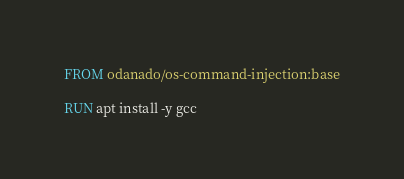Convert code to text. <code><loc_0><loc_0><loc_500><loc_500><_Dockerfile_>FROM odanado/os-command-injection:base

RUN apt install -y gcc
</code> 